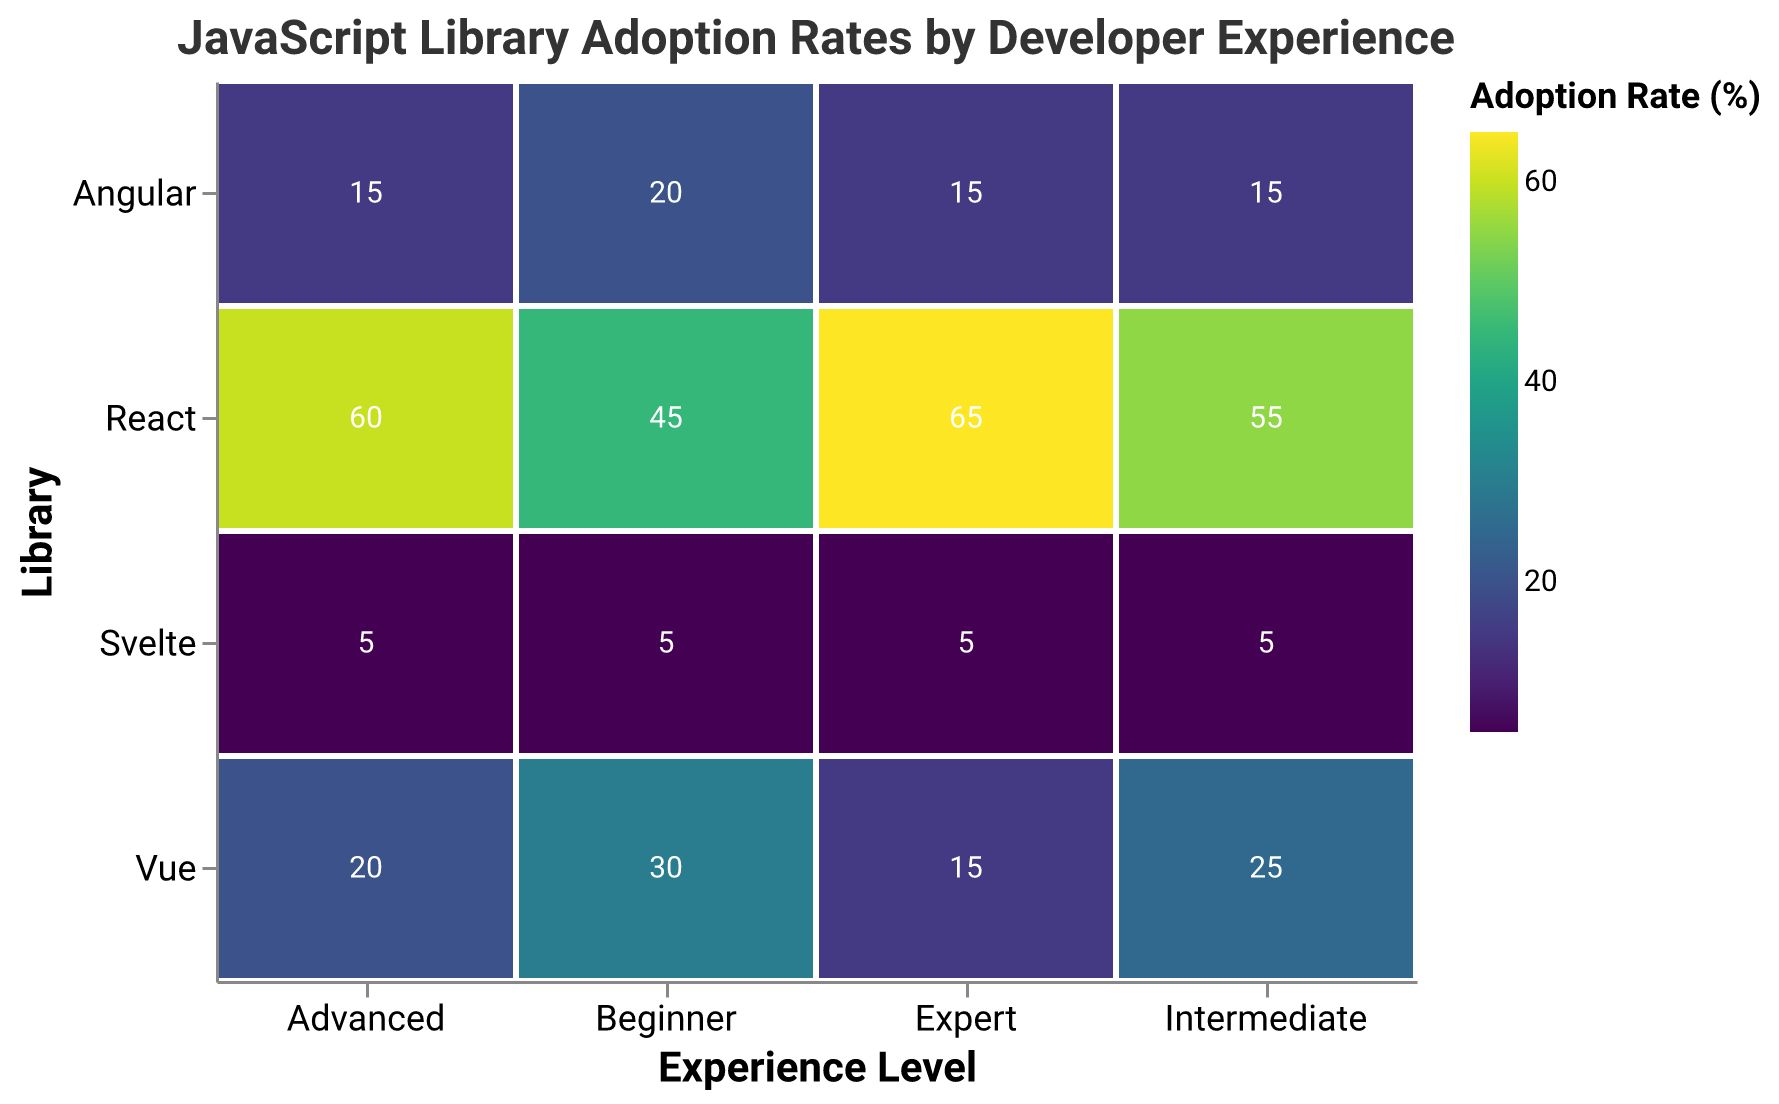How many experience levels are shown in the mosaic plot? There are 4 distinct experience levels labeled on the x-axis: "Beginner," "Intermediate," "Advanced," and "Expert.".
Answer: 4 Which library has the highest adoption rate among Beginner developers? Look at the "Beginner" column and identify the library with the darkest color, which represents the highest adoption rate. The darkest color corresponds to "React" with an adoption rate of 45%.
Answer: React What is the difference in adoption rate of React between Intermediate and Expert levels? Compare the React values for Intermediate (55%) and Expert (65%) levels. Subtract the Intermediate value from the Expert value: 65% - 55% = 10%.
Answer: 10% Which library maintains a consistent adoption rate across different experience levels? Look at the cells for each library across all experience levels. Svelte has the same adoption rate (5%) in all levels.
Answer: Svelte Which experience level shows the least adoption rate for Vue? Identify the column for Vue and compare the values across all experience levels. The smallest value occurs for the Expert level at 15%.
Answer: Expert What is the combined adoption rate of Angular across all experience levels? Sum the Angular adoption rates for all levels: 20% (Beginner) + 15% (Intermediate) + 15% (Advanced) + 15% (Expert) = 65%.
Answer: 65% What is the average adoption rate of Vue across all experience levels? Calculate the average by adding the values for Vue and dividing by the number of levels: (30% + 25% + 20% + 15%) / 4 = 22.5%.
Answer: 22.5% In which experience level is the difference between React and Vue adoption rates the greatest? Calculate the difference between React and Vue for each level: Beginner (45% - 30% = 15%), Intermediate (55% - 25% = 30%), Advanced (60% - 20% = 40%), Expert (65% - 15% = 50%). The greatest difference is at the Expert level with 50%.
Answer: Expert Which library shows the most significant increase in adoption rate from Beginner to Expert levels? Compare the values from Beginner to Expert for each library and look for the largest increase: React (45% to 65%, an increase of 20%), Vue (30% to 15%, a decrease of 15%), Angular (20% to 15%, a decrease of 5%), Svelte (5% to 5%, no change). React has the most significant increase of 20%.
Answer: React Compare the sum of adoption rates of React and Angular at the Intermediate level. Add the adoption rates for React (55%) and Angular (15%) at the Intermediate level: 55% + 15% = 70%.
Answer: 70% 